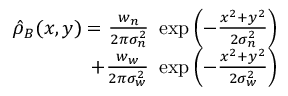Convert formula to latex. <formula><loc_0><loc_0><loc_500><loc_500>\begin{array} { r } { \hat { \rho } _ { B } ( x , y ) = \frac { w _ { n } } { 2 \pi \sigma _ { n } ^ { 2 } } \exp \left ( - \frac { x ^ { 2 } + y ^ { 2 } } { 2 \sigma _ { n } ^ { 2 } } \right ) } \\ { + \frac { w _ { w } } { 2 \pi \sigma _ { w } ^ { 2 } } \exp \left ( - \frac { x ^ { 2 } + y ^ { 2 } } { 2 \sigma _ { w } ^ { 2 } } \right ) } \end{array}</formula> 